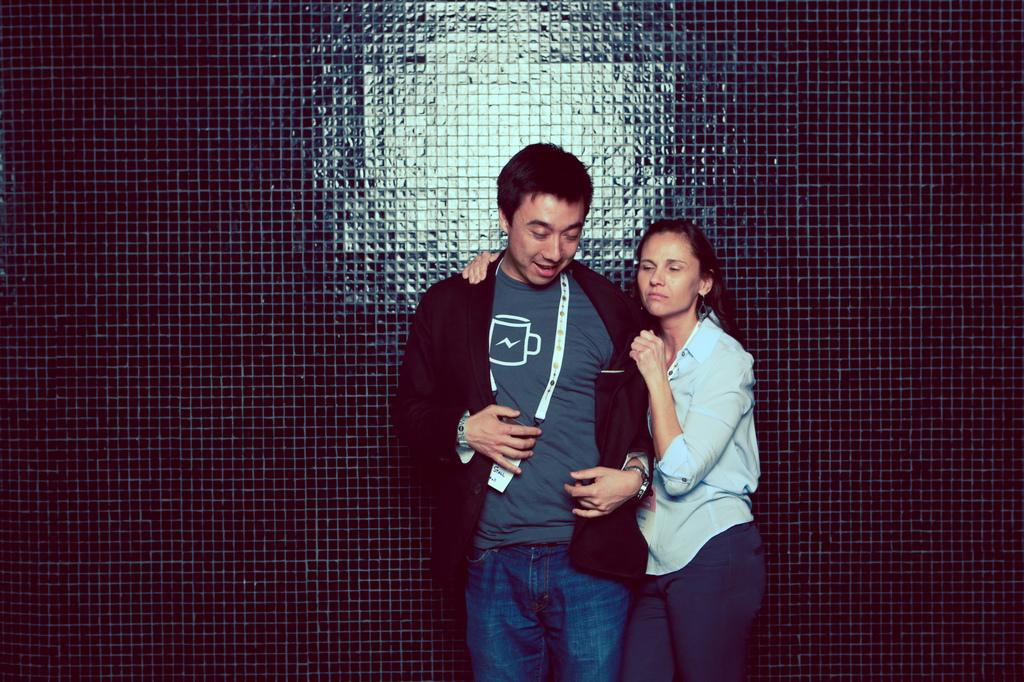How many people are in the image? There are two persons in the image. Can you describe the gender of the two persons? One of the persons is a man, and the other person is a woman. What is the man holding in the image? The man is holding an ID card. What accessory is the man wearing? The man is wearing a watch. What can be seen behind the two persons in the image? There is a large wall behind the two persons. What type of weather can be seen in the image? There is no indication of weather in the image, as it is focused on the two persons and the objects they are holding and wearing. 